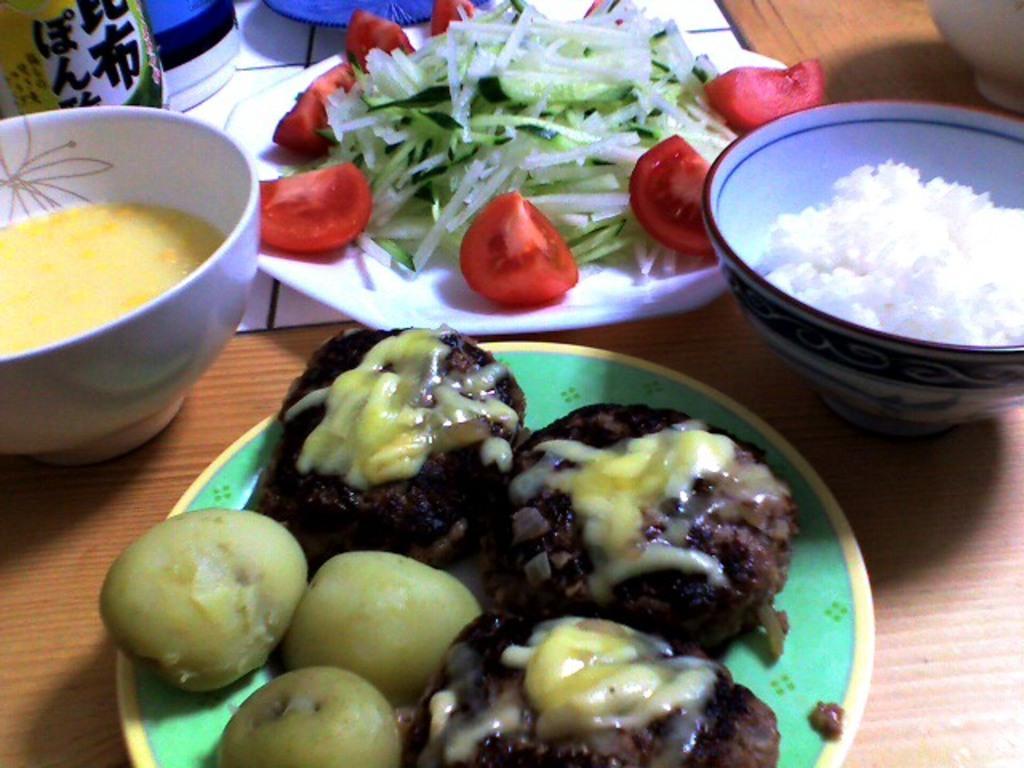How would you summarize this image in a sentence or two? In this image we can see food, plates, bowls, and other objects on a wooden platform. 